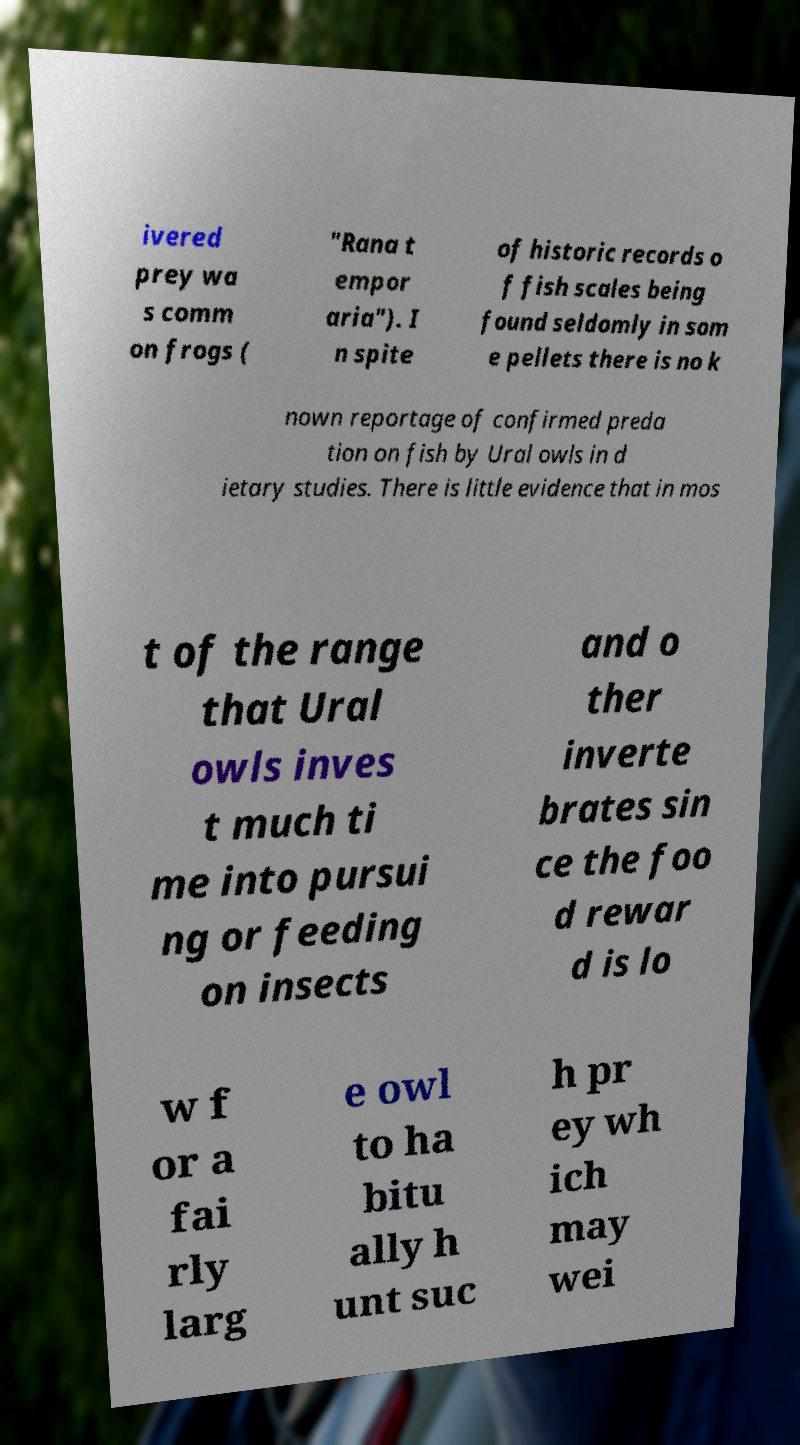For documentation purposes, I need the text within this image transcribed. Could you provide that? ivered prey wa s comm on frogs ( "Rana t empor aria"). I n spite of historic records o f fish scales being found seldomly in som e pellets there is no k nown reportage of confirmed preda tion on fish by Ural owls in d ietary studies. There is little evidence that in mos t of the range that Ural owls inves t much ti me into pursui ng or feeding on insects and o ther inverte brates sin ce the foo d rewar d is lo w f or a fai rly larg e owl to ha bitu ally h unt suc h pr ey wh ich may wei 